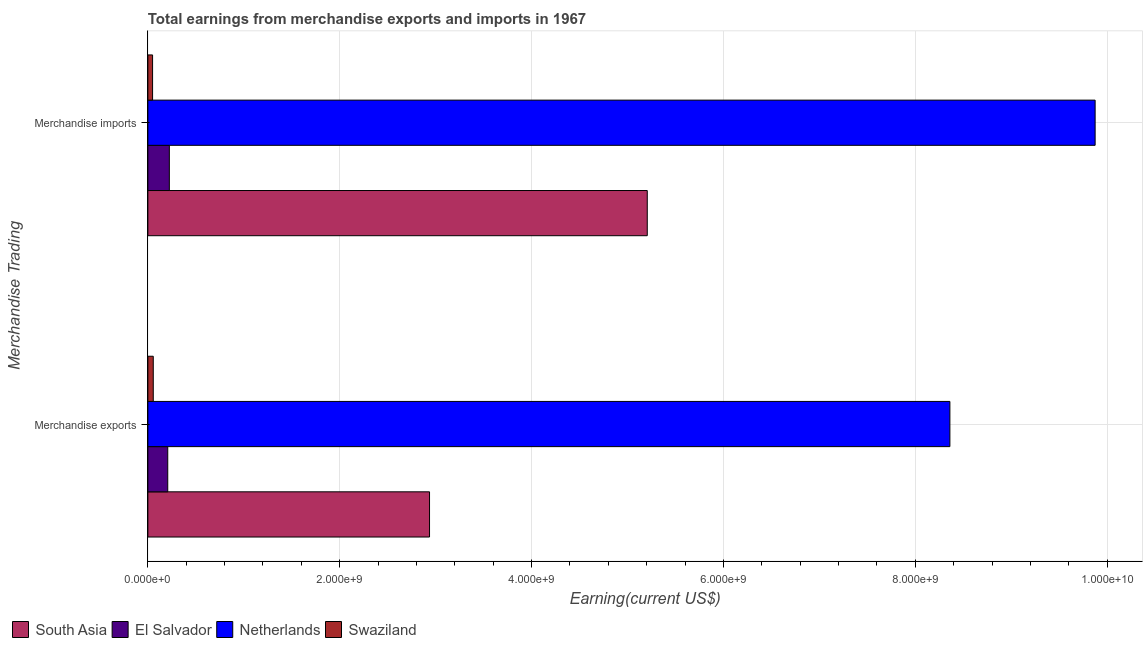How many different coloured bars are there?
Your answer should be compact. 4. How many groups of bars are there?
Your answer should be compact. 2. Are the number of bars on each tick of the Y-axis equal?
Your response must be concise. Yes. How many bars are there on the 1st tick from the top?
Ensure brevity in your answer.  4. What is the label of the 2nd group of bars from the top?
Your response must be concise. Merchandise exports. What is the earnings from merchandise exports in Netherlands?
Your response must be concise. 8.36e+09. Across all countries, what is the maximum earnings from merchandise exports?
Offer a terse response. 8.36e+09. Across all countries, what is the minimum earnings from merchandise exports?
Keep it short and to the point. 5.63e+07. In which country was the earnings from merchandise imports maximum?
Offer a terse response. Netherlands. In which country was the earnings from merchandise exports minimum?
Provide a short and direct response. Swaziland. What is the total earnings from merchandise imports in the graph?
Keep it short and to the point. 1.54e+1. What is the difference between the earnings from merchandise imports in Swaziland and that in El Salvador?
Give a very brief answer. -1.75e+08. What is the difference between the earnings from merchandise exports in Netherlands and the earnings from merchandise imports in South Asia?
Your answer should be very brief. 3.15e+09. What is the average earnings from merchandise exports per country?
Your answer should be very brief. 2.89e+09. What is the difference between the earnings from merchandise imports and earnings from merchandise exports in Swaziland?
Provide a succinct answer. -7.28e+06. In how many countries, is the earnings from merchandise exports greater than 6400000000 US$?
Your answer should be very brief. 1. What is the ratio of the earnings from merchandise exports in South Asia to that in Netherlands?
Keep it short and to the point. 0.35. Is the earnings from merchandise exports in El Salvador less than that in Swaziland?
Offer a terse response. No. In how many countries, is the earnings from merchandise exports greater than the average earnings from merchandise exports taken over all countries?
Make the answer very short. 2. What does the 1st bar from the top in Merchandise exports represents?
Your answer should be very brief. Swaziland. Are the values on the major ticks of X-axis written in scientific E-notation?
Give a very brief answer. Yes. Does the graph contain any zero values?
Keep it short and to the point. No. Does the graph contain grids?
Your answer should be compact. Yes. How many legend labels are there?
Your response must be concise. 4. What is the title of the graph?
Ensure brevity in your answer.  Total earnings from merchandise exports and imports in 1967. What is the label or title of the X-axis?
Your answer should be very brief. Earning(current US$). What is the label or title of the Y-axis?
Your answer should be very brief. Merchandise Trading. What is the Earning(current US$) of South Asia in Merchandise exports?
Make the answer very short. 2.94e+09. What is the Earning(current US$) in El Salvador in Merchandise exports?
Your answer should be compact. 2.07e+08. What is the Earning(current US$) in Netherlands in Merchandise exports?
Keep it short and to the point. 8.36e+09. What is the Earning(current US$) of Swaziland in Merchandise exports?
Give a very brief answer. 5.63e+07. What is the Earning(current US$) of South Asia in Merchandise imports?
Keep it short and to the point. 5.21e+09. What is the Earning(current US$) in El Salvador in Merchandise imports?
Ensure brevity in your answer.  2.24e+08. What is the Earning(current US$) of Netherlands in Merchandise imports?
Provide a succinct answer. 9.88e+09. What is the Earning(current US$) in Swaziland in Merchandise imports?
Your answer should be compact. 4.90e+07. Across all Merchandise Trading, what is the maximum Earning(current US$) in South Asia?
Give a very brief answer. 5.21e+09. Across all Merchandise Trading, what is the maximum Earning(current US$) in El Salvador?
Your answer should be very brief. 2.24e+08. Across all Merchandise Trading, what is the maximum Earning(current US$) of Netherlands?
Ensure brevity in your answer.  9.88e+09. Across all Merchandise Trading, what is the maximum Earning(current US$) in Swaziland?
Ensure brevity in your answer.  5.63e+07. Across all Merchandise Trading, what is the minimum Earning(current US$) in South Asia?
Your answer should be very brief. 2.94e+09. Across all Merchandise Trading, what is the minimum Earning(current US$) in El Salvador?
Provide a short and direct response. 2.07e+08. Across all Merchandise Trading, what is the minimum Earning(current US$) of Netherlands?
Give a very brief answer. 8.36e+09. Across all Merchandise Trading, what is the minimum Earning(current US$) in Swaziland?
Provide a short and direct response. 4.90e+07. What is the total Earning(current US$) of South Asia in the graph?
Provide a succinct answer. 8.14e+09. What is the total Earning(current US$) of El Salvador in the graph?
Your answer should be compact. 4.31e+08. What is the total Earning(current US$) in Netherlands in the graph?
Ensure brevity in your answer.  1.82e+1. What is the total Earning(current US$) of Swaziland in the graph?
Your response must be concise. 1.05e+08. What is the difference between the Earning(current US$) of South Asia in Merchandise exports and that in Merchandise imports?
Provide a succinct answer. -2.27e+09. What is the difference between the Earning(current US$) of El Salvador in Merchandise exports and that in Merchandise imports?
Keep it short and to the point. -1.67e+07. What is the difference between the Earning(current US$) of Netherlands in Merchandise exports and that in Merchandise imports?
Provide a short and direct response. -1.51e+09. What is the difference between the Earning(current US$) in Swaziland in Merchandise exports and that in Merchandise imports?
Your answer should be compact. 7.28e+06. What is the difference between the Earning(current US$) in South Asia in Merchandise exports and the Earning(current US$) in El Salvador in Merchandise imports?
Your answer should be compact. 2.71e+09. What is the difference between the Earning(current US$) in South Asia in Merchandise exports and the Earning(current US$) in Netherlands in Merchandise imports?
Offer a terse response. -6.94e+09. What is the difference between the Earning(current US$) of South Asia in Merchandise exports and the Earning(current US$) of Swaziland in Merchandise imports?
Provide a succinct answer. 2.89e+09. What is the difference between the Earning(current US$) of El Salvador in Merchandise exports and the Earning(current US$) of Netherlands in Merchandise imports?
Your response must be concise. -9.67e+09. What is the difference between the Earning(current US$) of El Salvador in Merchandise exports and the Earning(current US$) of Swaziland in Merchandise imports?
Ensure brevity in your answer.  1.58e+08. What is the difference between the Earning(current US$) in Netherlands in Merchandise exports and the Earning(current US$) in Swaziland in Merchandise imports?
Your answer should be compact. 8.31e+09. What is the average Earning(current US$) of South Asia per Merchandise Trading?
Provide a succinct answer. 4.07e+09. What is the average Earning(current US$) in El Salvador per Merchandise Trading?
Keep it short and to the point. 2.16e+08. What is the average Earning(current US$) in Netherlands per Merchandise Trading?
Give a very brief answer. 9.12e+09. What is the average Earning(current US$) in Swaziland per Merchandise Trading?
Your response must be concise. 5.27e+07. What is the difference between the Earning(current US$) of South Asia and Earning(current US$) of El Salvador in Merchandise exports?
Offer a very short reply. 2.73e+09. What is the difference between the Earning(current US$) in South Asia and Earning(current US$) in Netherlands in Merchandise exports?
Provide a short and direct response. -5.42e+09. What is the difference between the Earning(current US$) of South Asia and Earning(current US$) of Swaziland in Merchandise exports?
Ensure brevity in your answer.  2.88e+09. What is the difference between the Earning(current US$) of El Salvador and Earning(current US$) of Netherlands in Merchandise exports?
Offer a terse response. -8.15e+09. What is the difference between the Earning(current US$) of El Salvador and Earning(current US$) of Swaziland in Merchandise exports?
Ensure brevity in your answer.  1.51e+08. What is the difference between the Earning(current US$) of Netherlands and Earning(current US$) of Swaziland in Merchandise exports?
Give a very brief answer. 8.30e+09. What is the difference between the Earning(current US$) of South Asia and Earning(current US$) of El Salvador in Merchandise imports?
Offer a terse response. 4.98e+09. What is the difference between the Earning(current US$) of South Asia and Earning(current US$) of Netherlands in Merchandise imports?
Give a very brief answer. -4.67e+09. What is the difference between the Earning(current US$) in South Asia and Earning(current US$) in Swaziland in Merchandise imports?
Ensure brevity in your answer.  5.16e+09. What is the difference between the Earning(current US$) in El Salvador and Earning(current US$) in Netherlands in Merchandise imports?
Offer a terse response. -9.65e+09. What is the difference between the Earning(current US$) of El Salvador and Earning(current US$) of Swaziland in Merchandise imports?
Your answer should be very brief. 1.75e+08. What is the difference between the Earning(current US$) of Netherlands and Earning(current US$) of Swaziland in Merchandise imports?
Give a very brief answer. 9.83e+09. What is the ratio of the Earning(current US$) of South Asia in Merchandise exports to that in Merchandise imports?
Give a very brief answer. 0.56. What is the ratio of the Earning(current US$) of El Salvador in Merchandise exports to that in Merchandise imports?
Your response must be concise. 0.93. What is the ratio of the Earning(current US$) in Netherlands in Merchandise exports to that in Merchandise imports?
Your answer should be very brief. 0.85. What is the ratio of the Earning(current US$) in Swaziland in Merchandise exports to that in Merchandise imports?
Your answer should be compact. 1.15. What is the difference between the highest and the second highest Earning(current US$) of South Asia?
Ensure brevity in your answer.  2.27e+09. What is the difference between the highest and the second highest Earning(current US$) of El Salvador?
Your answer should be very brief. 1.67e+07. What is the difference between the highest and the second highest Earning(current US$) of Netherlands?
Ensure brevity in your answer.  1.51e+09. What is the difference between the highest and the second highest Earning(current US$) in Swaziland?
Keep it short and to the point. 7.28e+06. What is the difference between the highest and the lowest Earning(current US$) of South Asia?
Make the answer very short. 2.27e+09. What is the difference between the highest and the lowest Earning(current US$) in El Salvador?
Provide a succinct answer. 1.67e+07. What is the difference between the highest and the lowest Earning(current US$) of Netherlands?
Offer a very short reply. 1.51e+09. What is the difference between the highest and the lowest Earning(current US$) in Swaziland?
Offer a very short reply. 7.28e+06. 